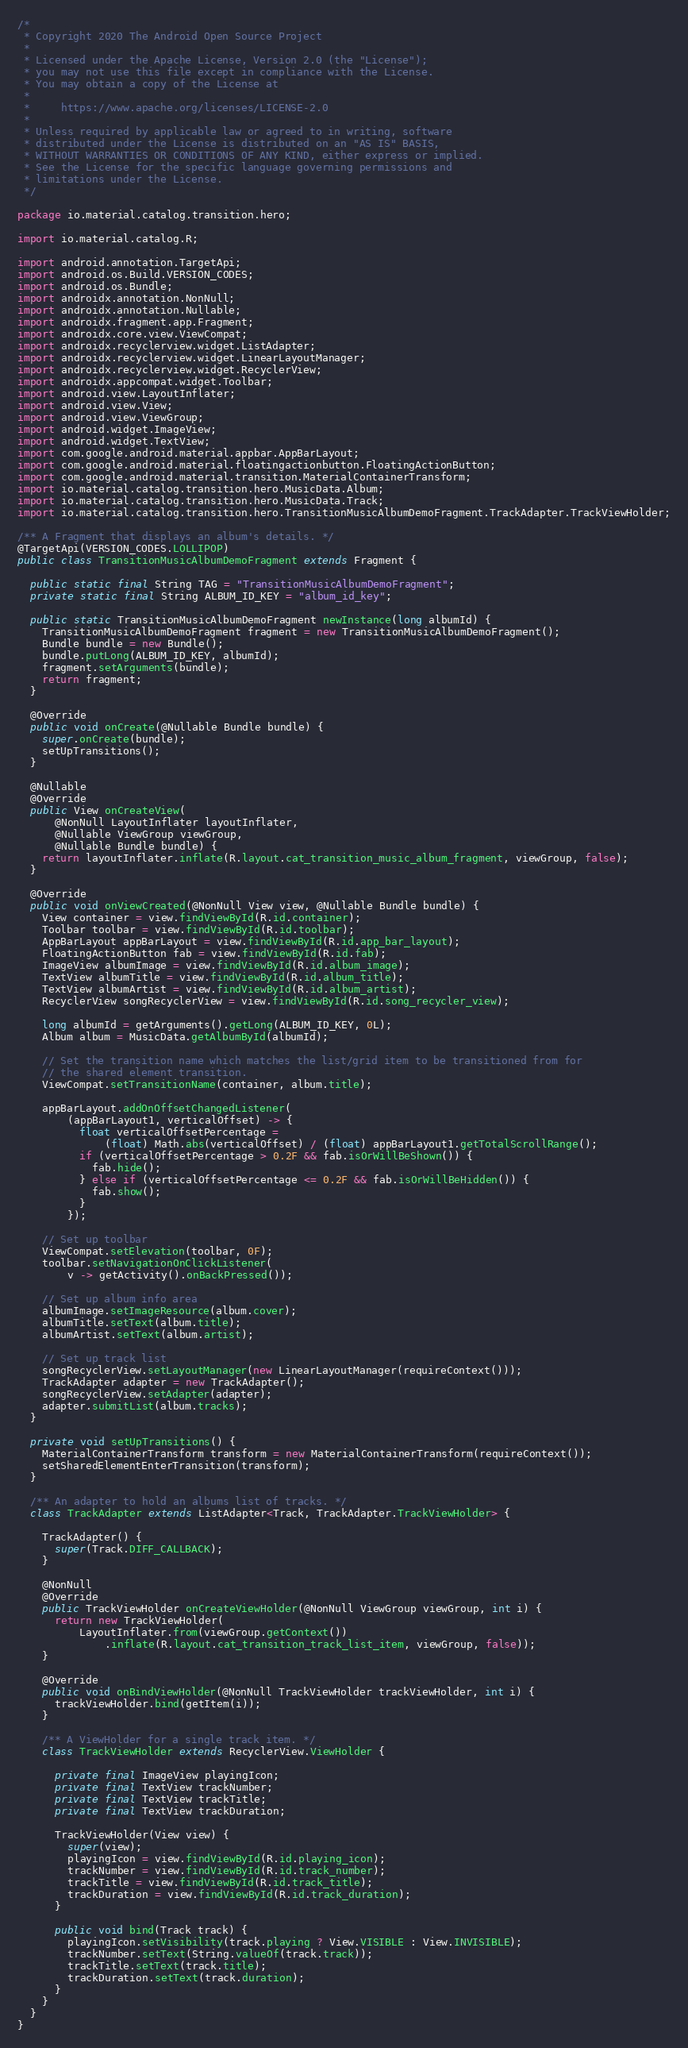<code> <loc_0><loc_0><loc_500><loc_500><_Java_>/*
 * Copyright 2020 The Android Open Source Project
 *
 * Licensed under the Apache License, Version 2.0 (the "License");
 * you may not use this file except in compliance with the License.
 * You may obtain a copy of the License at
 *
 *     https://www.apache.org/licenses/LICENSE-2.0
 *
 * Unless required by applicable law or agreed to in writing, software
 * distributed under the License is distributed on an "AS IS" BASIS,
 * WITHOUT WARRANTIES OR CONDITIONS OF ANY KIND, either express or implied.
 * See the License for the specific language governing permissions and
 * limitations under the License.
 */

package io.material.catalog.transition.hero;

import io.material.catalog.R;

import android.annotation.TargetApi;
import android.os.Build.VERSION_CODES;
import android.os.Bundle;
import androidx.annotation.NonNull;
import androidx.annotation.Nullable;
import androidx.fragment.app.Fragment;
import androidx.core.view.ViewCompat;
import androidx.recyclerview.widget.ListAdapter;
import androidx.recyclerview.widget.LinearLayoutManager;
import androidx.recyclerview.widget.RecyclerView;
import androidx.appcompat.widget.Toolbar;
import android.view.LayoutInflater;
import android.view.View;
import android.view.ViewGroup;
import android.widget.ImageView;
import android.widget.TextView;
import com.google.android.material.appbar.AppBarLayout;
import com.google.android.material.floatingactionbutton.FloatingActionButton;
import com.google.android.material.transition.MaterialContainerTransform;
import io.material.catalog.transition.hero.MusicData.Album;
import io.material.catalog.transition.hero.MusicData.Track;
import io.material.catalog.transition.hero.TransitionMusicAlbumDemoFragment.TrackAdapter.TrackViewHolder;

/** A Fragment that displays an album's details. */
@TargetApi(VERSION_CODES.LOLLIPOP)
public class TransitionMusicAlbumDemoFragment extends Fragment {

  public static final String TAG = "TransitionMusicAlbumDemoFragment";
  private static final String ALBUM_ID_KEY = "album_id_key";

  public static TransitionMusicAlbumDemoFragment newInstance(long albumId) {
    TransitionMusicAlbumDemoFragment fragment = new TransitionMusicAlbumDemoFragment();
    Bundle bundle = new Bundle();
    bundle.putLong(ALBUM_ID_KEY, albumId);
    fragment.setArguments(bundle);
    return fragment;
  }

  @Override
  public void onCreate(@Nullable Bundle bundle) {
    super.onCreate(bundle);
    setUpTransitions();
  }

  @Nullable
  @Override
  public View onCreateView(
      @NonNull LayoutInflater layoutInflater,
      @Nullable ViewGroup viewGroup,
      @Nullable Bundle bundle) {
    return layoutInflater.inflate(R.layout.cat_transition_music_album_fragment, viewGroup, false);
  }

  @Override
  public void onViewCreated(@NonNull View view, @Nullable Bundle bundle) {
    View container = view.findViewById(R.id.container);
    Toolbar toolbar = view.findViewById(R.id.toolbar);
    AppBarLayout appBarLayout = view.findViewById(R.id.app_bar_layout);
    FloatingActionButton fab = view.findViewById(R.id.fab);
    ImageView albumImage = view.findViewById(R.id.album_image);
    TextView albumTitle = view.findViewById(R.id.album_title);
    TextView albumArtist = view.findViewById(R.id.album_artist);
    RecyclerView songRecyclerView = view.findViewById(R.id.song_recycler_view);

    long albumId = getArguments().getLong(ALBUM_ID_KEY, 0L);
    Album album = MusicData.getAlbumById(albumId);

    // Set the transition name which matches the list/grid item to be transitioned from for
    // the shared element transition.
    ViewCompat.setTransitionName(container, album.title);

    appBarLayout.addOnOffsetChangedListener(
        (appBarLayout1, verticalOffset) -> {
          float verticalOffsetPercentage =
              (float) Math.abs(verticalOffset) / (float) appBarLayout1.getTotalScrollRange();
          if (verticalOffsetPercentage > 0.2F && fab.isOrWillBeShown()) {
            fab.hide();
          } else if (verticalOffsetPercentage <= 0.2F && fab.isOrWillBeHidden()) {
            fab.show();
          }
        });

    // Set up toolbar
    ViewCompat.setElevation(toolbar, 0F);
    toolbar.setNavigationOnClickListener(
        v -> getActivity().onBackPressed());

    // Set up album info area
    albumImage.setImageResource(album.cover);
    albumTitle.setText(album.title);
    albumArtist.setText(album.artist);

    // Set up track list
    songRecyclerView.setLayoutManager(new LinearLayoutManager(requireContext()));
    TrackAdapter adapter = new TrackAdapter();
    songRecyclerView.setAdapter(adapter);
    adapter.submitList(album.tracks);
  }

  private void setUpTransitions() {
    MaterialContainerTransform transform = new MaterialContainerTransform(requireContext());
    setSharedElementEnterTransition(transform);
  }

  /** An adapter to hold an albums list of tracks. */
  class TrackAdapter extends ListAdapter<Track, TrackAdapter.TrackViewHolder> {

    TrackAdapter() {
      super(Track.DIFF_CALLBACK);
    }

    @NonNull
    @Override
    public TrackViewHolder onCreateViewHolder(@NonNull ViewGroup viewGroup, int i) {
      return new TrackViewHolder(
          LayoutInflater.from(viewGroup.getContext())
              .inflate(R.layout.cat_transition_track_list_item, viewGroup, false));
    }

    @Override
    public void onBindViewHolder(@NonNull TrackViewHolder trackViewHolder, int i) {
      trackViewHolder.bind(getItem(i));
    }

    /** A ViewHolder for a single track item. */
    class TrackViewHolder extends RecyclerView.ViewHolder {

      private final ImageView playingIcon;
      private final TextView trackNumber;
      private final TextView trackTitle;
      private final TextView trackDuration;

      TrackViewHolder(View view) {
        super(view);
        playingIcon = view.findViewById(R.id.playing_icon);
        trackNumber = view.findViewById(R.id.track_number);
        trackTitle = view.findViewById(R.id.track_title);
        trackDuration = view.findViewById(R.id.track_duration);
      }

      public void bind(Track track) {
        playingIcon.setVisibility(track.playing ? View.VISIBLE : View.INVISIBLE);
        trackNumber.setText(String.valueOf(track.track));
        trackTitle.setText(track.title);
        trackDuration.setText(track.duration);
      }
    }
  }
}
</code> 